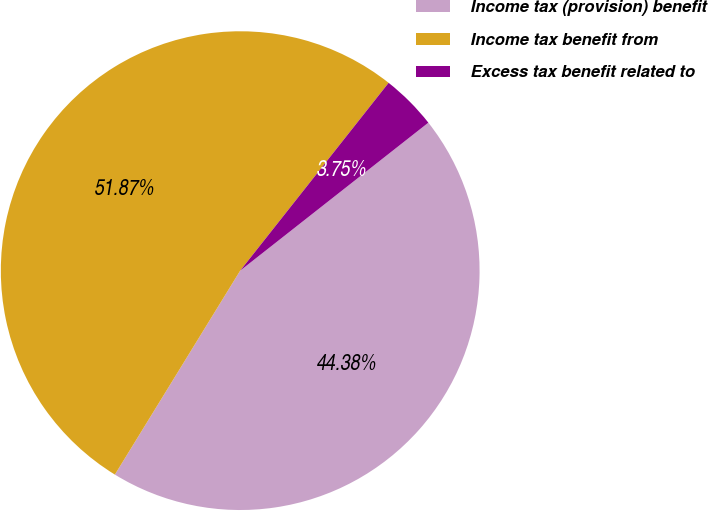<chart> <loc_0><loc_0><loc_500><loc_500><pie_chart><fcel>Income tax (provision) benefit<fcel>Income tax benefit from<fcel>Excess tax benefit related to<nl><fcel>44.38%<fcel>51.88%<fcel>3.75%<nl></chart> 